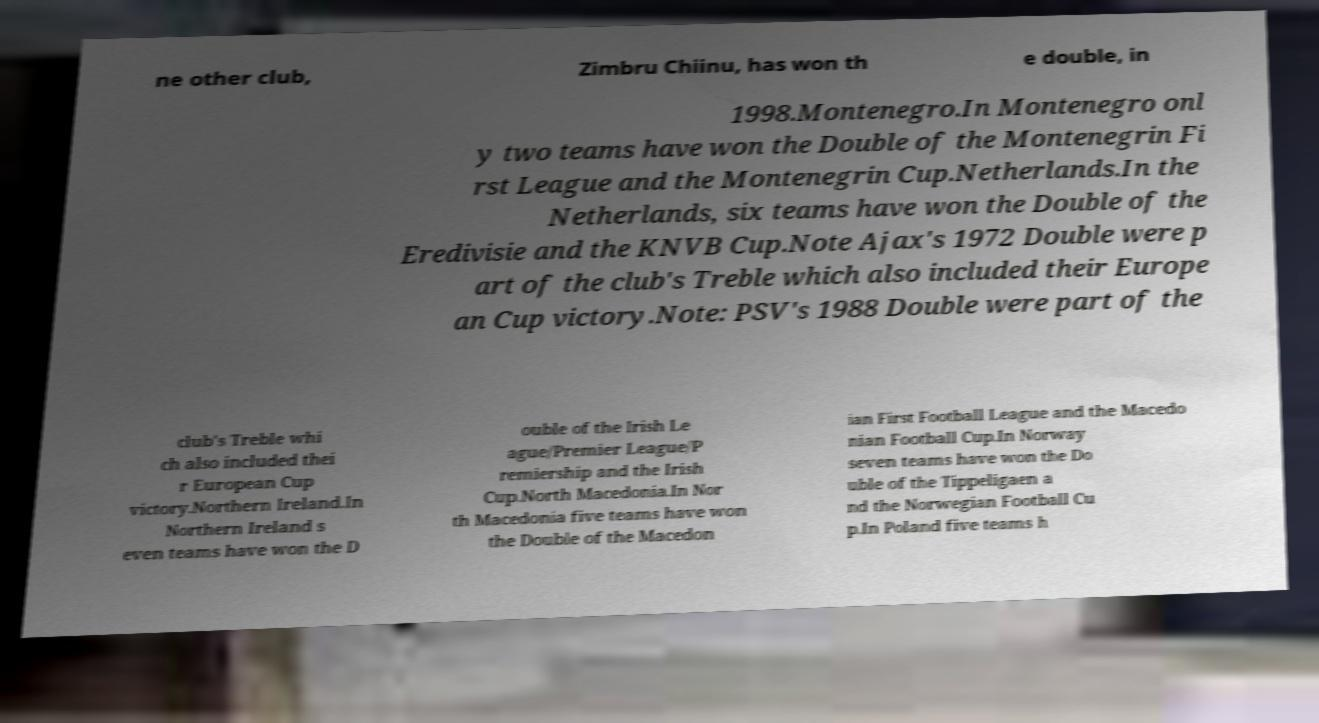Can you accurately transcribe the text from the provided image for me? ne other club, Zimbru Chiinu, has won th e double, in 1998.Montenegro.In Montenegro onl y two teams have won the Double of the Montenegrin Fi rst League and the Montenegrin Cup.Netherlands.In the Netherlands, six teams have won the Double of the Eredivisie and the KNVB Cup.Note Ajax's 1972 Double were p art of the club's Treble which also included their Europe an Cup victory.Note: PSV's 1988 Double were part of the club's Treble whi ch also included thei r European Cup victory.Northern Ireland.In Northern Ireland s even teams have won the D ouble of the Irish Le ague/Premier League/P remiership and the Irish Cup.North Macedonia.In Nor th Macedonia five teams have won the Double of the Macedon ian First Football League and the Macedo nian Football Cup.In Norway seven teams have won the Do uble of the Tippeligaen a nd the Norwegian Football Cu p.In Poland five teams h 